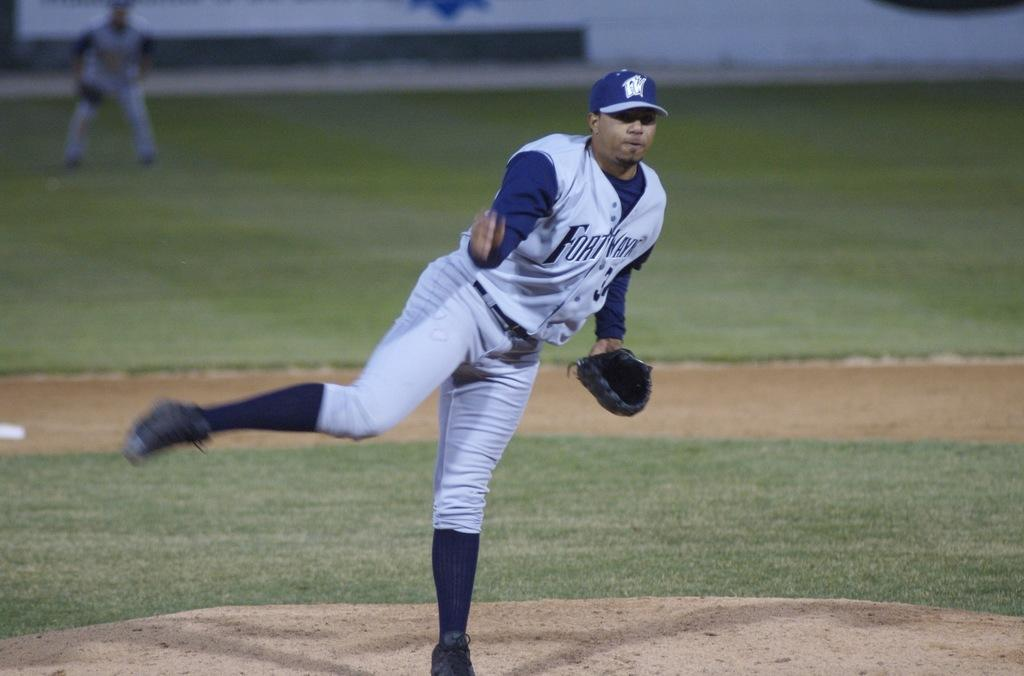How many people are in the image? There are two players in the image. Where are the players located? The players are on a ground. What can be observed about the background of the image? The background of the image is blurred. What type of calculator is being used by the players in the image? There is no calculator present in the image. Are the players making any payments in the image? There is no indication of any payments being made in the image. 